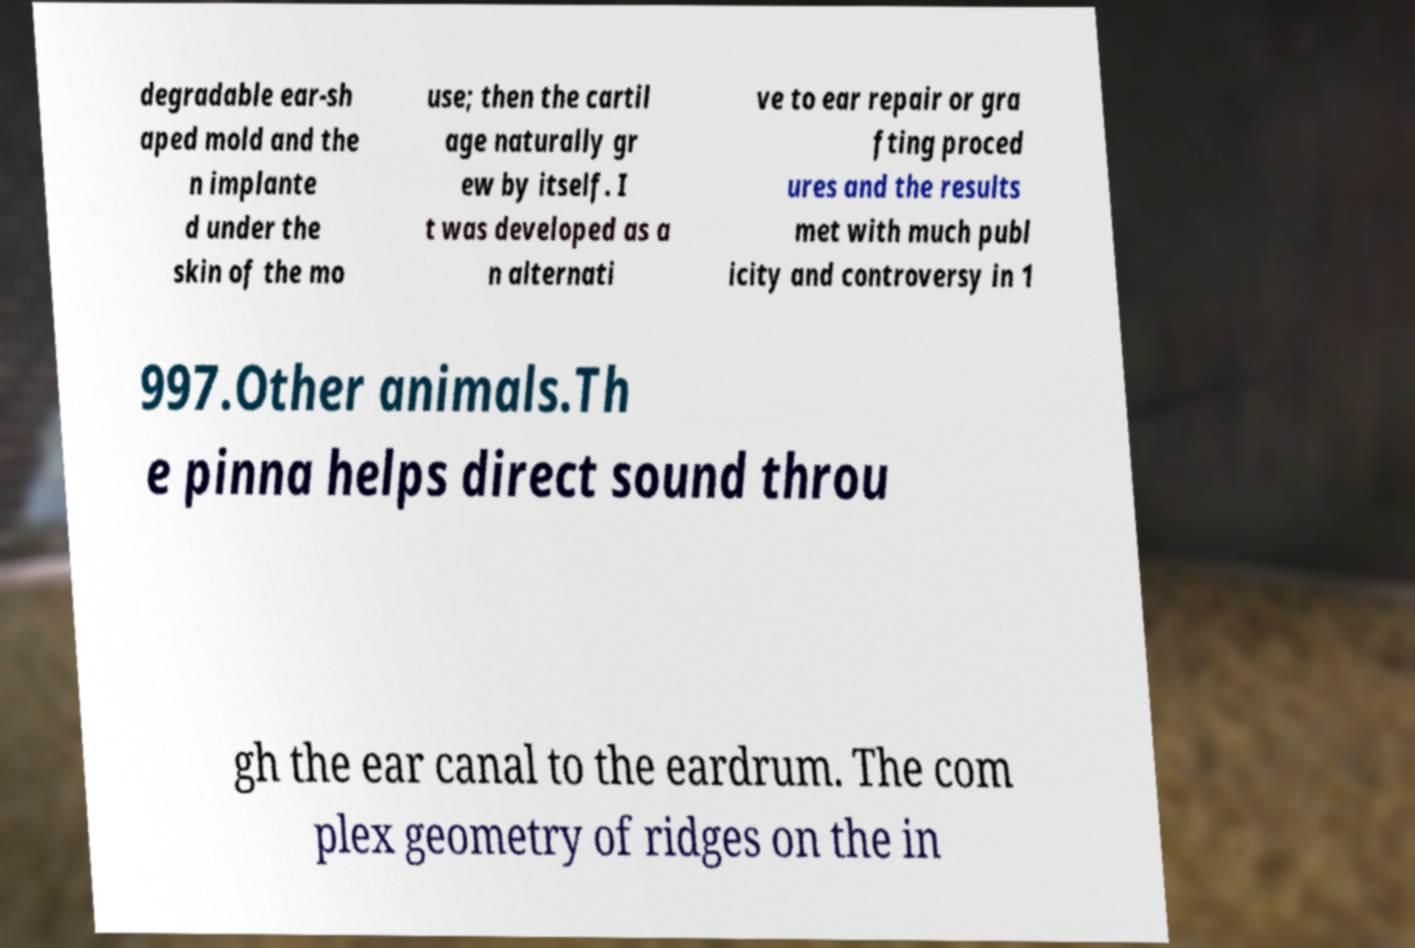Please read and relay the text visible in this image. What does it say? degradable ear-sh aped mold and the n implante d under the skin of the mo use; then the cartil age naturally gr ew by itself. I t was developed as a n alternati ve to ear repair or gra fting proced ures and the results met with much publ icity and controversy in 1 997.Other animals.Th e pinna helps direct sound throu gh the ear canal to the eardrum. The com plex geometry of ridges on the in 